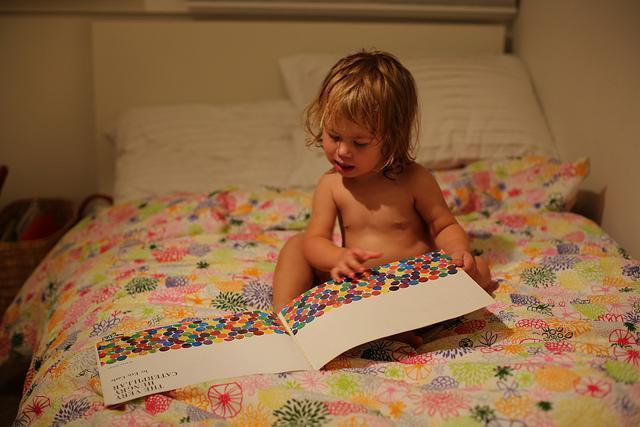On what does the child focus here?
Make your selection from the four choices given to correctly answer the question.
Options: Words, dots, white space, music. Dots. 